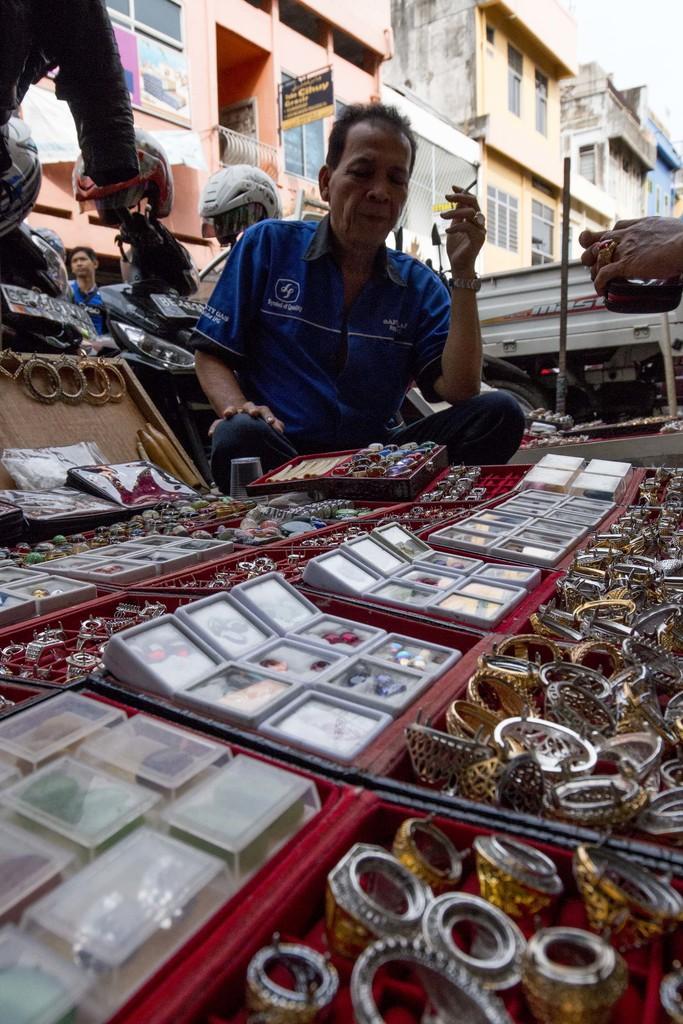In one or two sentences, can you explain what this image depicts? In this image we can see some people. In that a man is holding a cigarette and the other is wearing a helmet. In the foreground we can see a group of accessories placed in the boxes. On the backside we can see a pole, some buildings with windows, the signboard and the sky. 